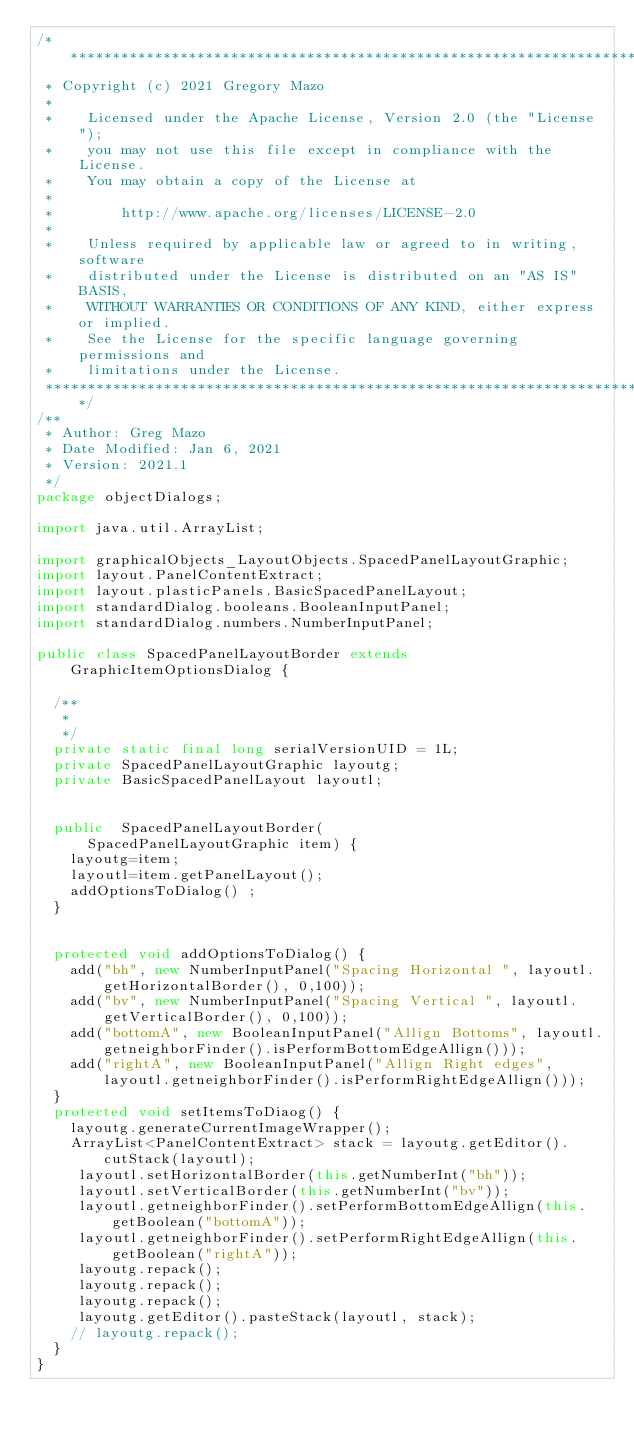<code> <loc_0><loc_0><loc_500><loc_500><_Java_>/*******************************************************************************
 * Copyright (c) 2021 Gregory Mazo
 *
 *    Licensed under the Apache License, Version 2.0 (the "License");
 *    you may not use this file except in compliance with the License.
 *    You may obtain a copy of the License at
 *
 *        http://www.apache.org/licenses/LICENSE-2.0
 *
 *    Unless required by applicable law or agreed to in writing, software
 *    distributed under the License is distributed on an "AS IS" BASIS,
 *    WITHOUT WARRANTIES OR CONDITIONS OF ANY KIND, either express or implied.
 *    See the License for the specific language governing permissions and
 *    limitations under the License.
 *******************************************************************************/
/**
 * Author: Greg Mazo
 * Date Modified: Jan 6, 2021
 * Version: 2021.1
 */
package objectDialogs;

import java.util.ArrayList;

import graphicalObjects_LayoutObjects.SpacedPanelLayoutGraphic;
import layout.PanelContentExtract;
import layout.plasticPanels.BasicSpacedPanelLayout;
import standardDialog.booleans.BooleanInputPanel;
import standardDialog.numbers.NumberInputPanel;

public class SpacedPanelLayoutBorder extends GraphicItemOptionsDialog {

	/**
	 * 
	 */
	private static final long serialVersionUID = 1L;
	private SpacedPanelLayoutGraphic layoutg;
	private BasicSpacedPanelLayout layoutl;

	
	public  SpacedPanelLayoutBorder(
			SpacedPanelLayoutGraphic item) {
		layoutg=item;
		layoutl=item.getPanelLayout();
		addOptionsToDialog() ;
	}
	
	
	protected void addOptionsToDialog() {
		add("bh", new NumberInputPanel("Spacing Horizontal ", layoutl.getHorizontalBorder(), 0,100));
		add("bv", new NumberInputPanel("Spacing Vertical ", layoutl.getVerticalBorder(), 0,100));
		add("bottomA", new BooleanInputPanel("Allign Bottoms", layoutl.getneighborFinder().isPerformBottomEdgeAllign()));
		add("rightA", new BooleanInputPanel("Allign Right edges", layoutl.getneighborFinder().isPerformRightEdgeAllign()));
	}
	protected void setItemsToDiaog() {
		layoutg.generateCurrentImageWrapper();
		ArrayList<PanelContentExtract> stack = layoutg.getEditor().cutStack(layoutl);
		 layoutl.setHorizontalBorder(this.getNumberInt("bh"));
		 layoutl.setVerticalBorder(this.getNumberInt("bv"));
		 layoutl.getneighborFinder().setPerformBottomEdgeAllign(this.getBoolean("bottomA"));
		 layoutl.getneighborFinder().setPerformRightEdgeAllign(this.getBoolean("rightA"));
		 layoutg.repack();
		 layoutg.repack();
		 layoutg.repack();
		 layoutg.getEditor().pasteStack(layoutl, stack);
		// layoutg.repack();
	}
}
</code> 